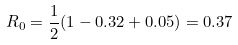<formula> <loc_0><loc_0><loc_500><loc_500>R _ { 0 } = \frac { 1 } { 2 } ( 1 - 0 . 3 2 + 0 . 0 5 ) = 0 . 3 7</formula> 